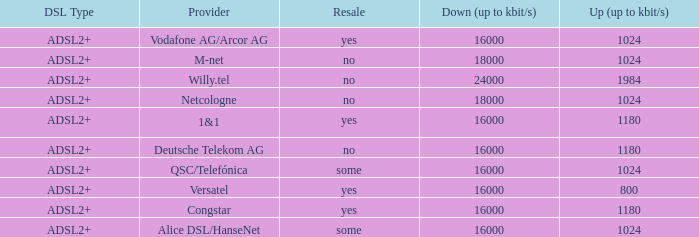What are all the dsl type offered by the M-Net telecom company? ADSL2+. 